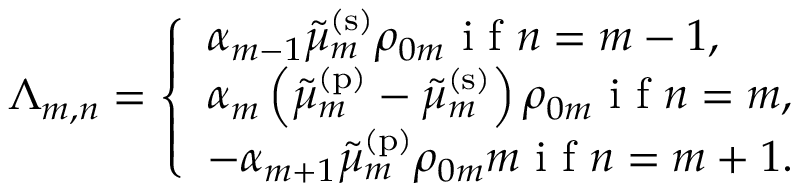Convert formula to latex. <formula><loc_0><loc_0><loc_500><loc_500>\Lambda _ { m , n } = \left \{ \begin{array} { l l } { \alpha _ { m - 1 } \tilde { \mu } _ { m } ^ { ( s ) } \rho _ { 0 m } i f n = m - 1 , } \\ { \alpha _ { m } \left ( \tilde { \mu } _ { m } ^ { ( p ) } - \tilde { \mu } _ { m } ^ { ( s ) } \right ) \rho _ { 0 m } i f n = m , } \\ { - \alpha _ { m + 1 } \tilde { \mu } _ { m } ^ { ( p ) } \rho _ { 0 m } m i f n = m + 1 . } \end{array}</formula> 